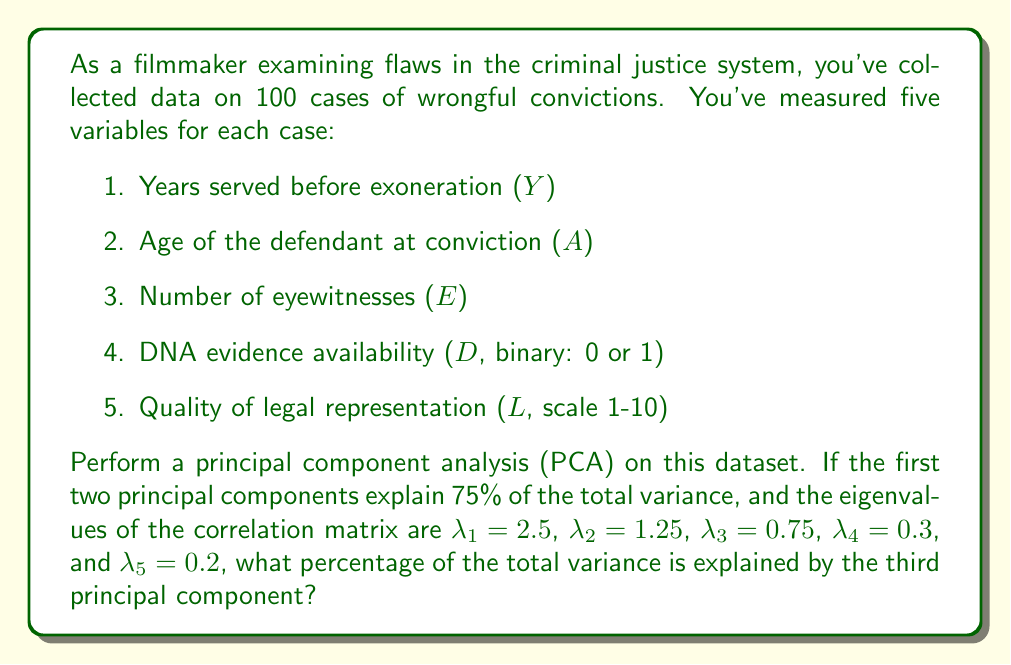Can you answer this question? To solve this problem, we need to follow these steps:

1) First, recall that in PCA, each principal component corresponds to an eigenvalue of the correlation matrix. The eigenvalues represent the amount of variance explained by each principal component.

2) The total variance in a dataset with standardized variables is equal to the number of variables. In this case, we have 5 variables, so the total variance is 5.

3) The proportion of variance explained by each principal component is calculated by dividing its corresponding eigenvalue by the total variance:

   $\text{Proportion of variance} = \frac{\lambda_i}{\sum \lambda_i} = \frac{\lambda_i}{5}$

4) We're told that the first two principal components explain 75% of the total variance. Let's verify this:

   $\frac{\lambda_1 + \lambda_2}{5} = \frac{2.5 + 1.25}{5} = \frac{3.75}{5} = 0.75 = 75\%$

5) To find the percentage of variance explained by the third principal component, we use the same formula:

   $\text{Proportion of variance} = \frac{\lambda_3}{5} = \frac{0.75}{5} = 0.15$

6) Convert this to a percentage:

   $0.15 \times 100\% = 15\%$

Therefore, the third principal component explains 15% of the total variance.
Answer: 15% 